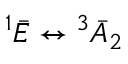<formula> <loc_0><loc_0><loc_500><loc_500>^ { 1 } \bar { E } \leftrightarrow { ^ { 3 } \bar { A } _ { 2 } }</formula> 